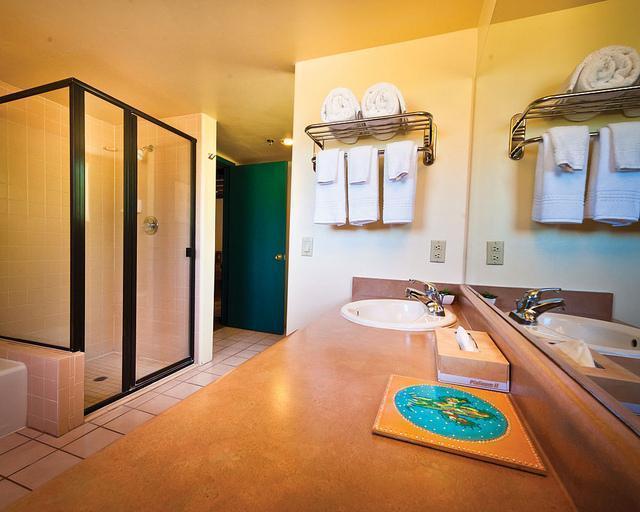How many towels are seen?
Give a very brief answer. 8. How many sinks are there?
Give a very brief answer. 2. 